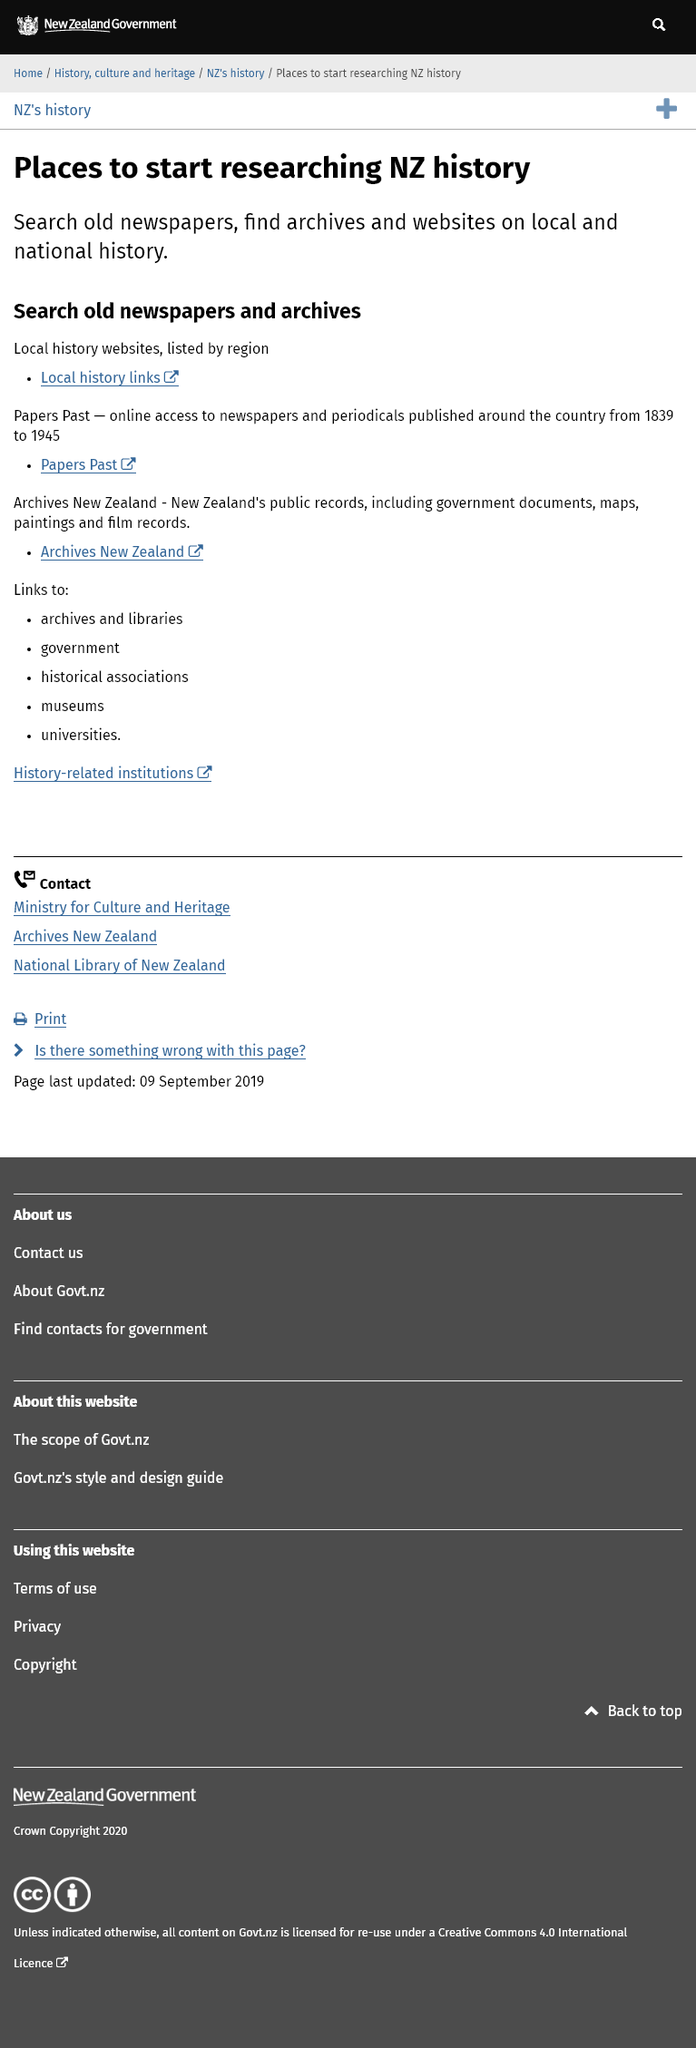Give some essential details in this illustration. To research New Zealand history, you can use old newspapers, archives, and websites on local and national history, which provide a wealth of information and insights into the country's rich past. New Zealand's public records consist of government documents, maps, paintings, and film records. Local history websites are classified and organized based on regions. 